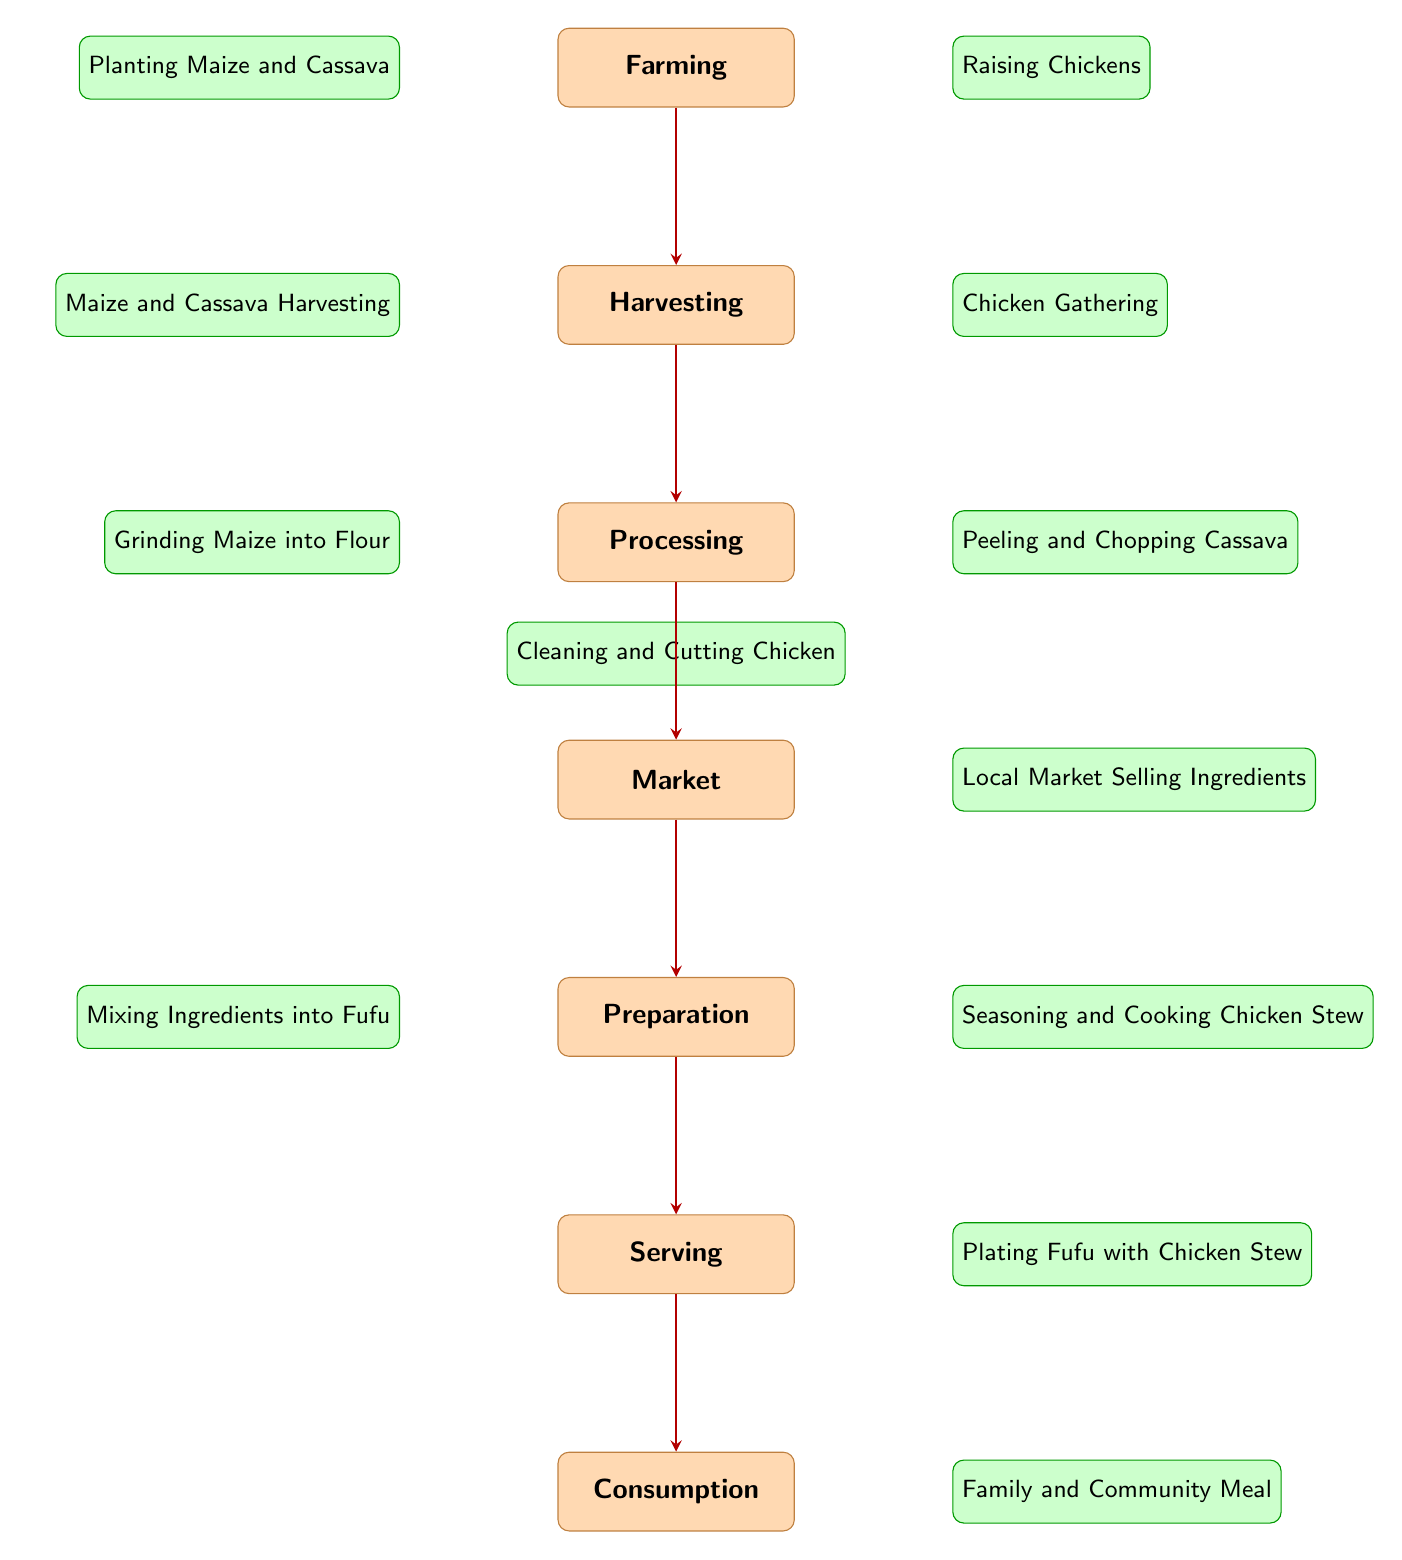What is the first stage in the food chain? The diagram clearly indicates that the first stage, at the top, is "Farming." This is where the food chain begins, before any other processes take place.
Answer: Farming How many elements are involved in the preparation stage? In the preparation stage, there are two elements: "Mixing Ingredients into Fufu" and "Seasoning and Cooking Chicken Stew." Counting these gives a total of two elements.
Answer: 2 What is the last stage in the food chain? According to the diagram, the last stage is "Consumption," which appears at the bottom, indicating the final step in the food chain where the food is eaten.
Answer: Consumption What elements are involved in processing? The processing stage includes three elements: "Grinding Maize into Flour," "Peeling and Chopping Cassava," and "Cleaning and Cutting Chicken." These elements are all key processes in preparing the food.
Answer: Grinding Maize into Flour, Peeling and Chopping Cassava, Cleaning and Cutting Chicken Which stage comes immediately after the market? The diagram shows a direct arrow from the "Market" stage to the "Preparation" stage, indicating that preparation follows immediately after the market stage in the food chain.
Answer: Preparation If you gather chickens, what is the next stage? Following the "Chicken Gathering" in the harvesting stage, the next stage is "Processing." This movement is depicted as a flow from harvesting directly to processing.
Answer: Processing Which ingredients are planted in the farming stage? The farming stage mentions two ingredients specifically planted: "Maize" and "Cassava." These are the crops involved in the initial farming process.
Answer: Maize and Cassava What type of meal is depicted in the consumption stage? The consumption stage highlights the "Family and Community Meal," suggesting that the food is enjoyed collectively among family or community members after preparation.
Answer: Family and Community Meal What is sold at the local market according to the diagram? The diagram indicates that the "Local Market Selling Ingredients" stage contains the ingredients that have been gathered and processed prior, ready for sale at the market.
Answer: Local Market Selling Ingredients 